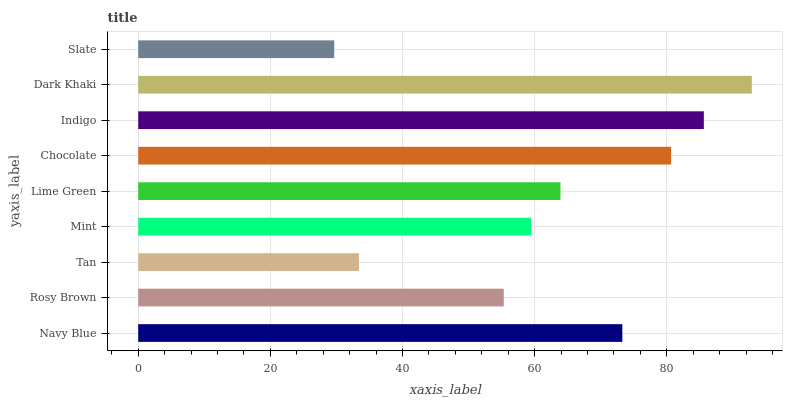Is Slate the minimum?
Answer yes or no. Yes. Is Dark Khaki the maximum?
Answer yes or no. Yes. Is Rosy Brown the minimum?
Answer yes or no. No. Is Rosy Brown the maximum?
Answer yes or no. No. Is Navy Blue greater than Rosy Brown?
Answer yes or no. Yes. Is Rosy Brown less than Navy Blue?
Answer yes or no. Yes. Is Rosy Brown greater than Navy Blue?
Answer yes or no. No. Is Navy Blue less than Rosy Brown?
Answer yes or no. No. Is Lime Green the high median?
Answer yes or no. Yes. Is Lime Green the low median?
Answer yes or no. Yes. Is Mint the high median?
Answer yes or no. No. Is Tan the low median?
Answer yes or no. No. 